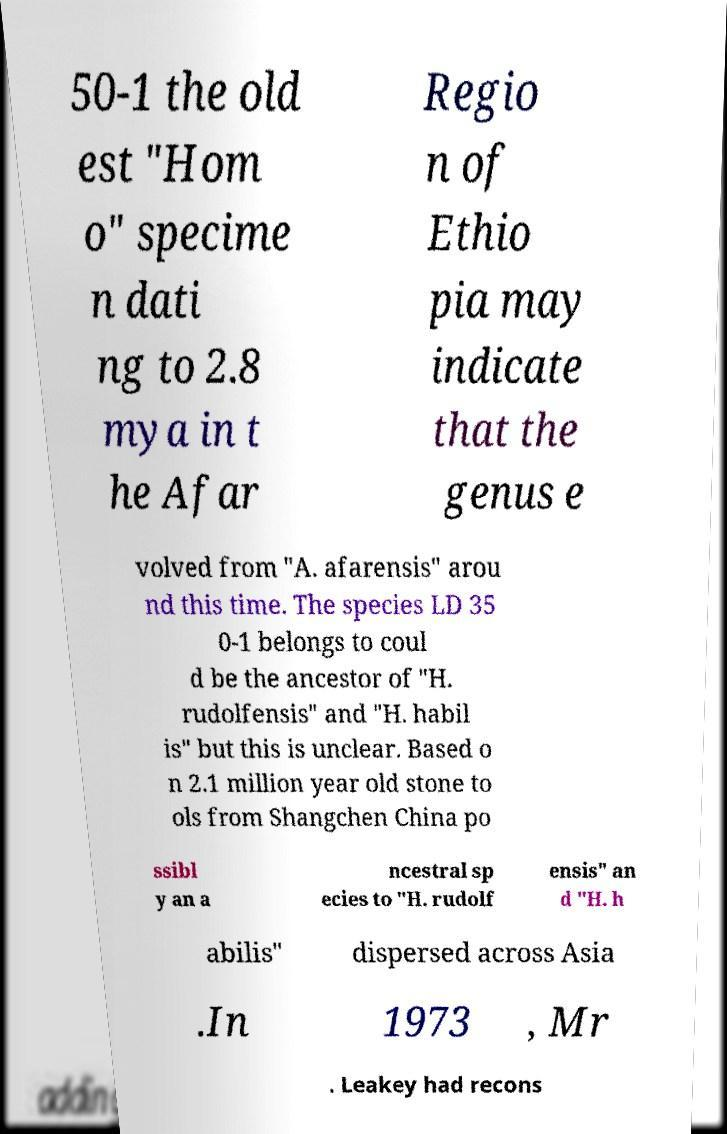What messages or text are displayed in this image? I need them in a readable, typed format. 50-1 the old est "Hom o" specime n dati ng to 2.8 mya in t he Afar Regio n of Ethio pia may indicate that the genus e volved from "A. afarensis" arou nd this time. The species LD 35 0-1 belongs to coul d be the ancestor of "H. rudolfensis" and "H. habil is" but this is unclear. Based o n 2.1 million year old stone to ols from Shangchen China po ssibl y an a ncestral sp ecies to "H. rudolf ensis" an d "H. h abilis" dispersed across Asia .In 1973 , Mr . Leakey had recons 